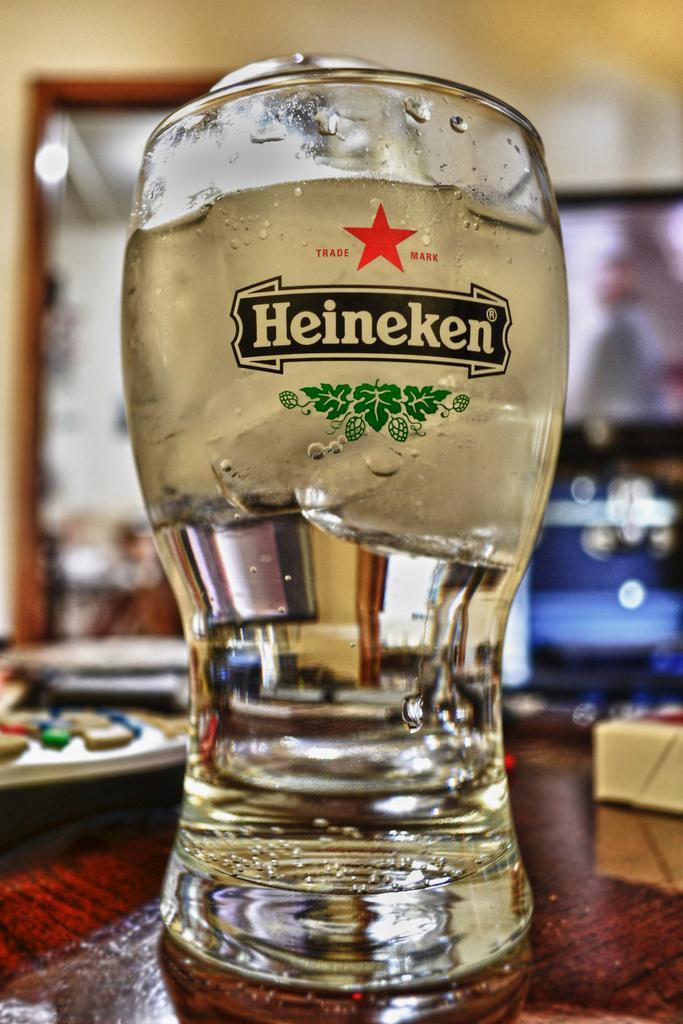Please provide a concise description of this image. In this image there is a table and we can see a wine glass, remote and some objects placed on the table. In the background there is a wall and a door. 